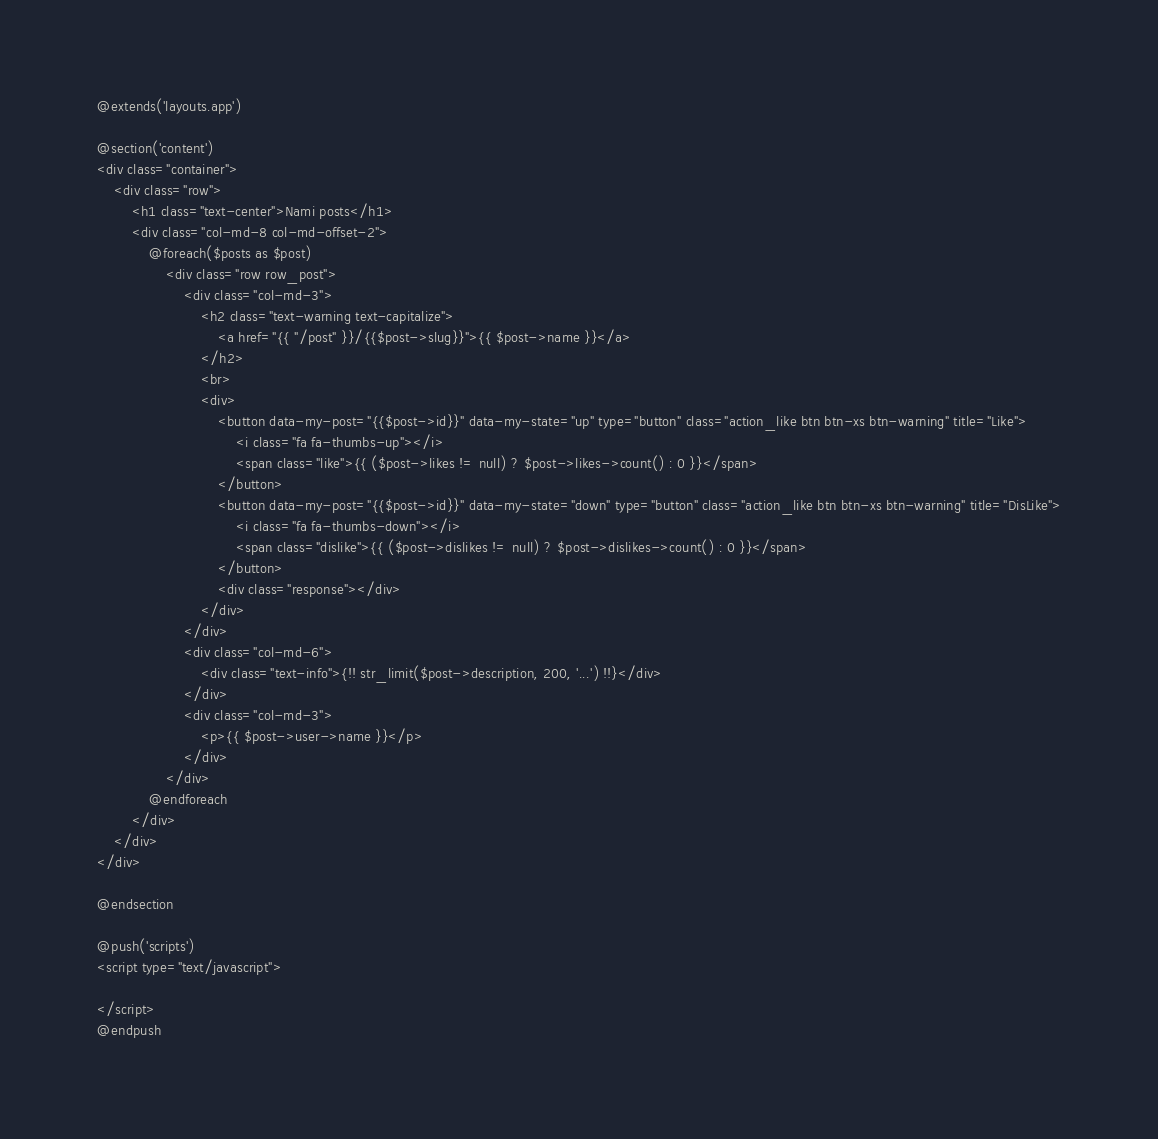<code> <loc_0><loc_0><loc_500><loc_500><_PHP_>@extends('layouts.app')

@section('content')
<div class="container">
    <div class="row">
        <h1 class="text-center">Nami posts</h1>
        <div class="col-md-8 col-md-offset-2">
            @foreach($posts as $post)
                <div class="row row_post">
                    <div class="col-md-3">
                        <h2 class="text-warning text-capitalize">
                            <a href="{{ "/post" }}/{{$post->slug}}">{{ $post->name }}</a>
                        </h2>
                        <br>
                        <div>
                            <button data-my-post="{{$post->id}}" data-my-state="up" type="button" class="action_like btn btn-xs btn-warning" title="Like">
                                <i class="fa fa-thumbs-up"></i>
                                <span class="like">{{ ($post->likes != null) ? $post->likes->count() : 0 }}</span>
                            </button>
                            <button data-my-post="{{$post->id}}" data-my-state="down" type="button" class="action_like btn btn-xs btn-warning" title="DisLike">
                                <i class="fa fa-thumbs-down"></i>
                                <span class="dislike">{{ ($post->dislikes != null) ? $post->dislikes->count() : 0 }}</span>
                            </button>
                            <div class="response"></div>
                        </div>
                    </div>
                    <div class="col-md-6">
                        <div class="text-info">{!! str_limit($post->description, 200, '...') !!}</div>
                    </div>
                    <div class="col-md-3">
                        <p>{{ $post->user->name }}</p>
                    </div>
                </div>
            @endforeach
        </div>
    </div>
</div>

@endsection

@push('scripts')
<script type="text/javascript">

</script>
@endpush</code> 